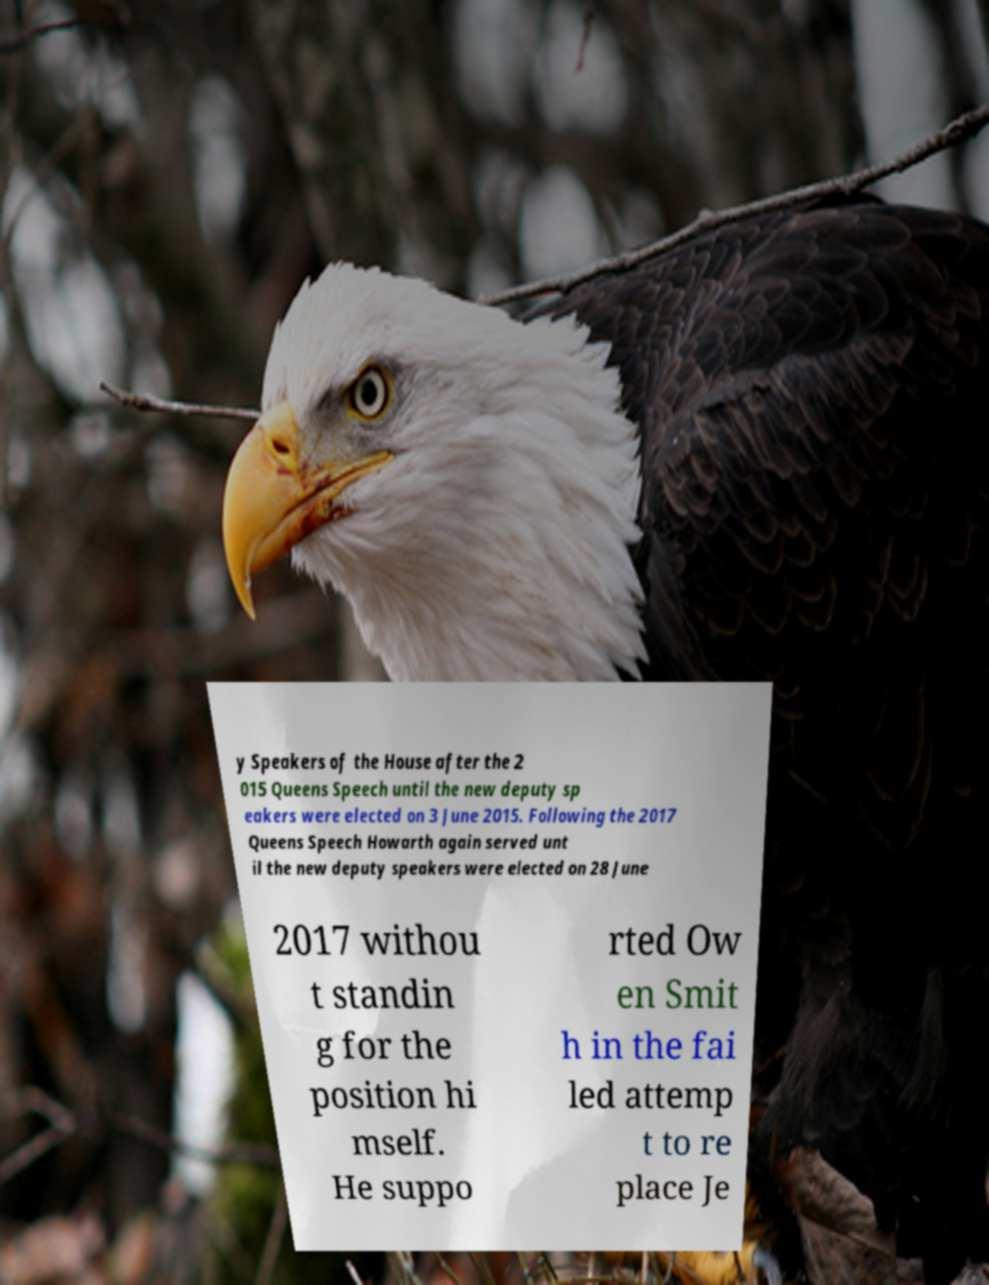What messages or text are displayed in this image? I need them in a readable, typed format. y Speakers of the House after the 2 015 Queens Speech until the new deputy sp eakers were elected on 3 June 2015. Following the 2017 Queens Speech Howarth again served unt il the new deputy speakers were elected on 28 June 2017 withou t standin g for the position hi mself. He suppo rted Ow en Smit h in the fai led attemp t to re place Je 